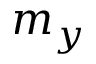Convert formula to latex. <formula><loc_0><loc_0><loc_500><loc_500>m _ { y }</formula> 